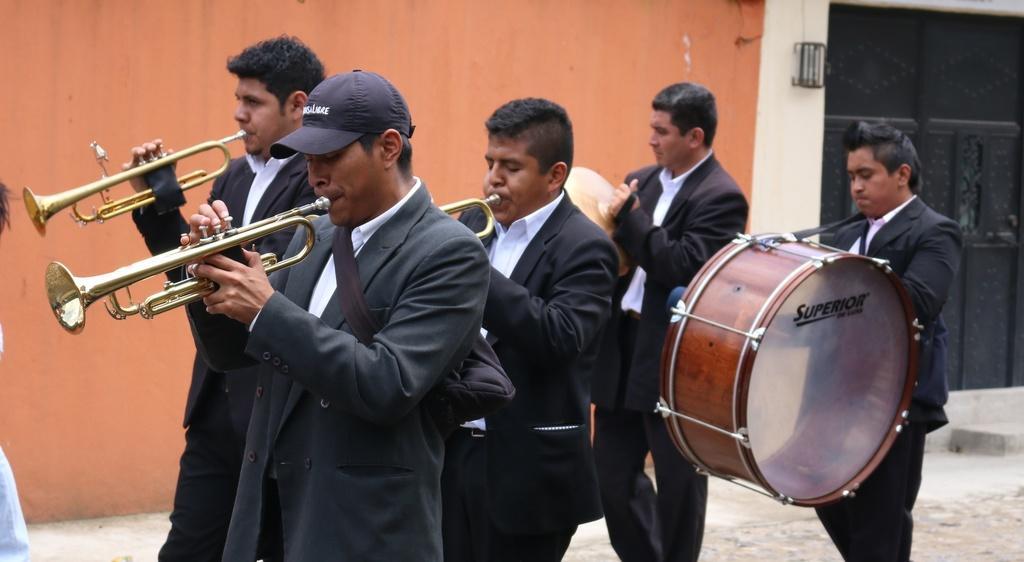How would you summarize this image in a sentence or two? In this image there are people on the floor. They are holding the musical instruments. Background there is a wall. Left side there is a person wearing a cap. 